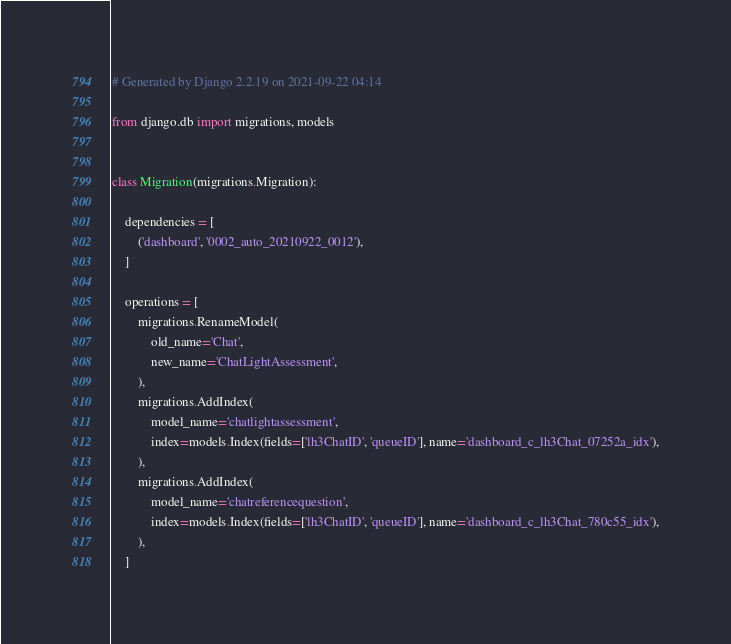Convert code to text. <code><loc_0><loc_0><loc_500><loc_500><_Python_># Generated by Django 2.2.19 on 2021-09-22 04:14

from django.db import migrations, models


class Migration(migrations.Migration):

    dependencies = [
        ('dashboard', '0002_auto_20210922_0012'),
    ]

    operations = [
        migrations.RenameModel(
            old_name='Chat',
            new_name='ChatLightAssessment',
        ),
        migrations.AddIndex(
            model_name='chatlightassessment',
            index=models.Index(fields=['lh3ChatID', 'queueID'], name='dashboard_c_lh3Chat_07252a_idx'),
        ),
        migrations.AddIndex(
            model_name='chatreferencequestion',
            index=models.Index(fields=['lh3ChatID', 'queueID'], name='dashboard_c_lh3Chat_780c55_idx'),
        ),
    ]
</code> 